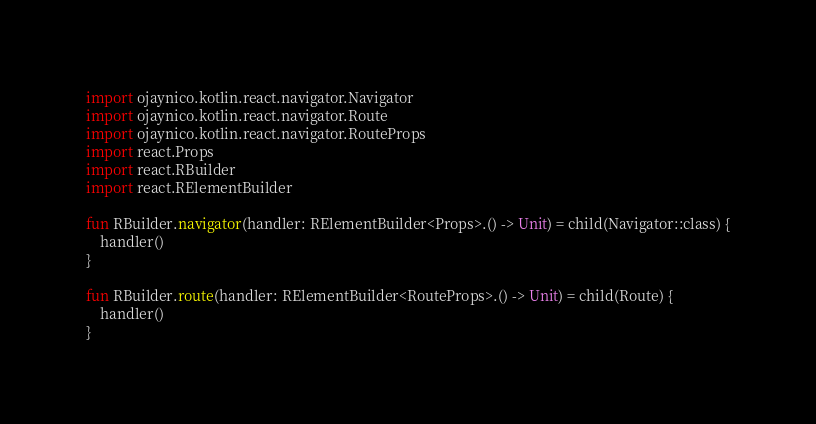<code> <loc_0><loc_0><loc_500><loc_500><_Kotlin_>
import ojaynico.kotlin.react.navigator.Navigator
import ojaynico.kotlin.react.navigator.Route
import ojaynico.kotlin.react.navigator.RouteProps
import react.Props
import react.RBuilder
import react.RElementBuilder

fun RBuilder.navigator(handler: RElementBuilder<Props>.() -> Unit) = child(Navigator::class) {
    handler()
}

fun RBuilder.route(handler: RElementBuilder<RouteProps>.() -> Unit) = child(Route) {
    handler()
}
</code> 